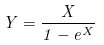Convert formula to latex. <formula><loc_0><loc_0><loc_500><loc_500>Y = \frac { X } { 1 - e ^ { X } }</formula> 